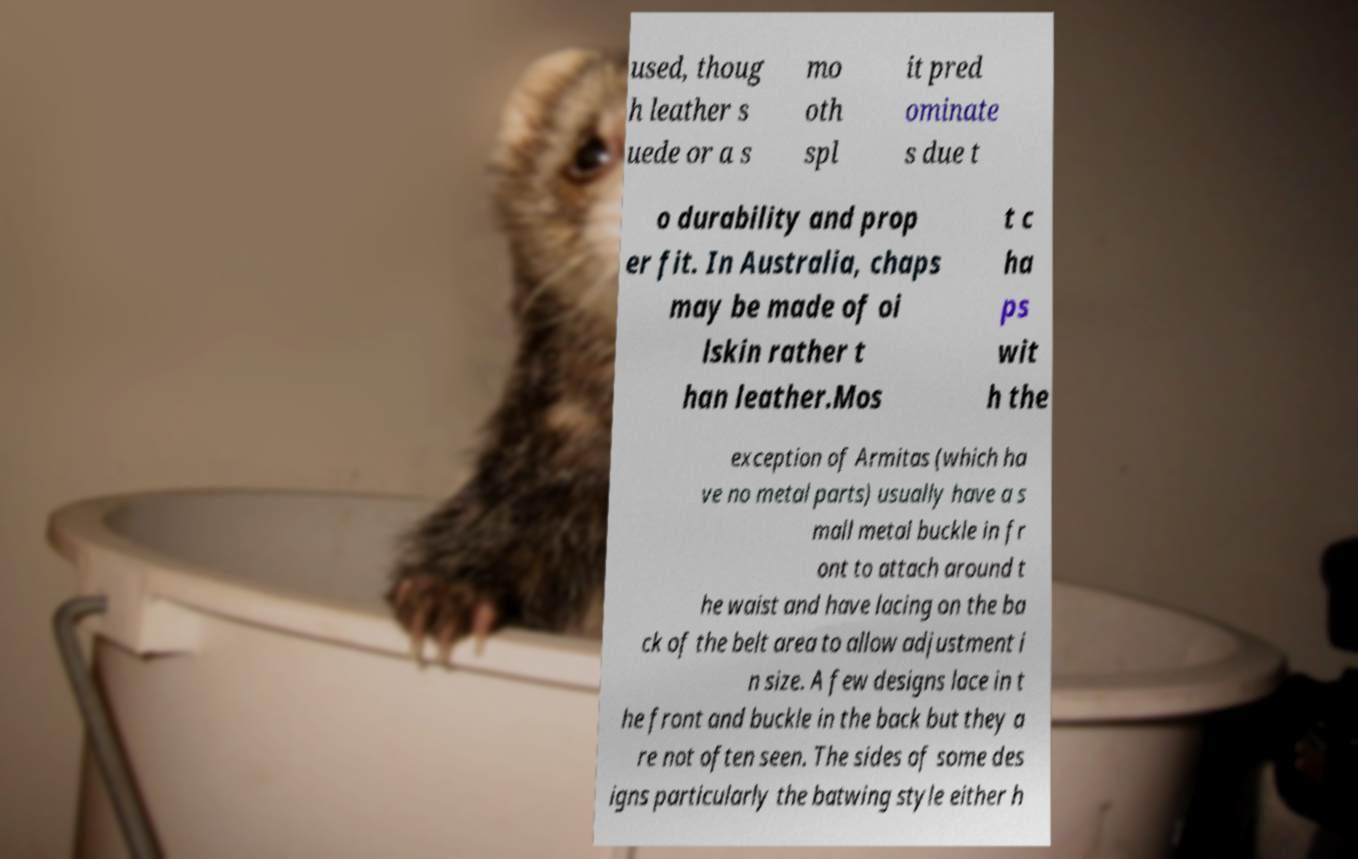Please identify and transcribe the text found in this image. used, thoug h leather s uede or a s mo oth spl it pred ominate s due t o durability and prop er fit. In Australia, chaps may be made of oi lskin rather t han leather.Mos t c ha ps wit h the exception of Armitas (which ha ve no metal parts) usually have a s mall metal buckle in fr ont to attach around t he waist and have lacing on the ba ck of the belt area to allow adjustment i n size. A few designs lace in t he front and buckle in the back but they a re not often seen. The sides of some des igns particularly the batwing style either h 